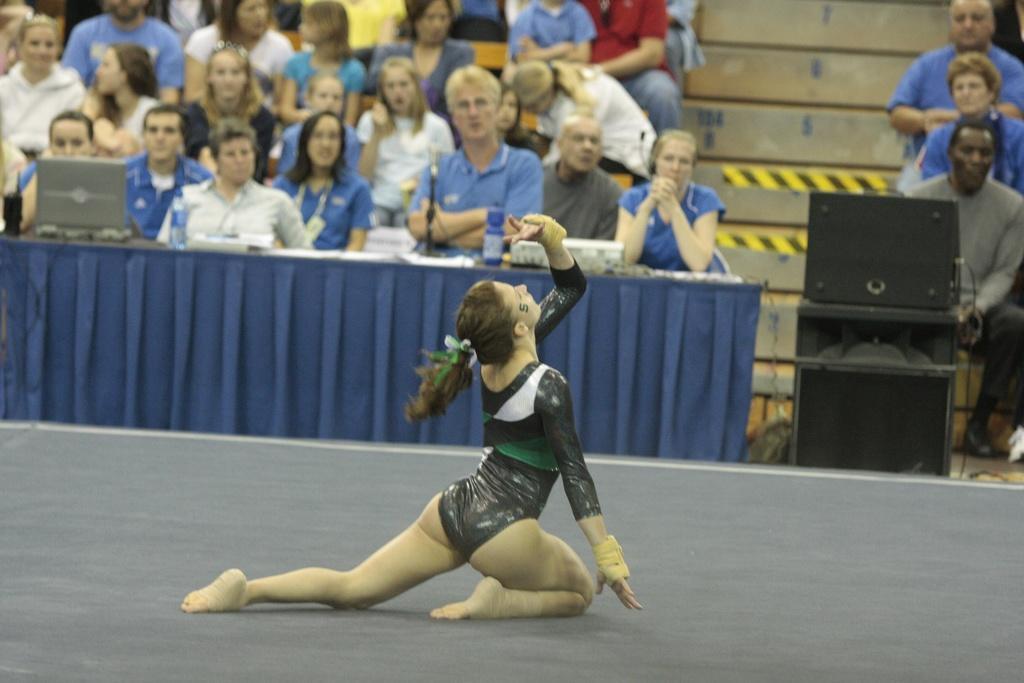In one or two sentences, can you explain what this image depicts? In this image, we can see a woman is on the floor. Background we can see a group of people are sitting. Here we can see laptop, cloth, bottles, some objects, boxes, wires and wall. 